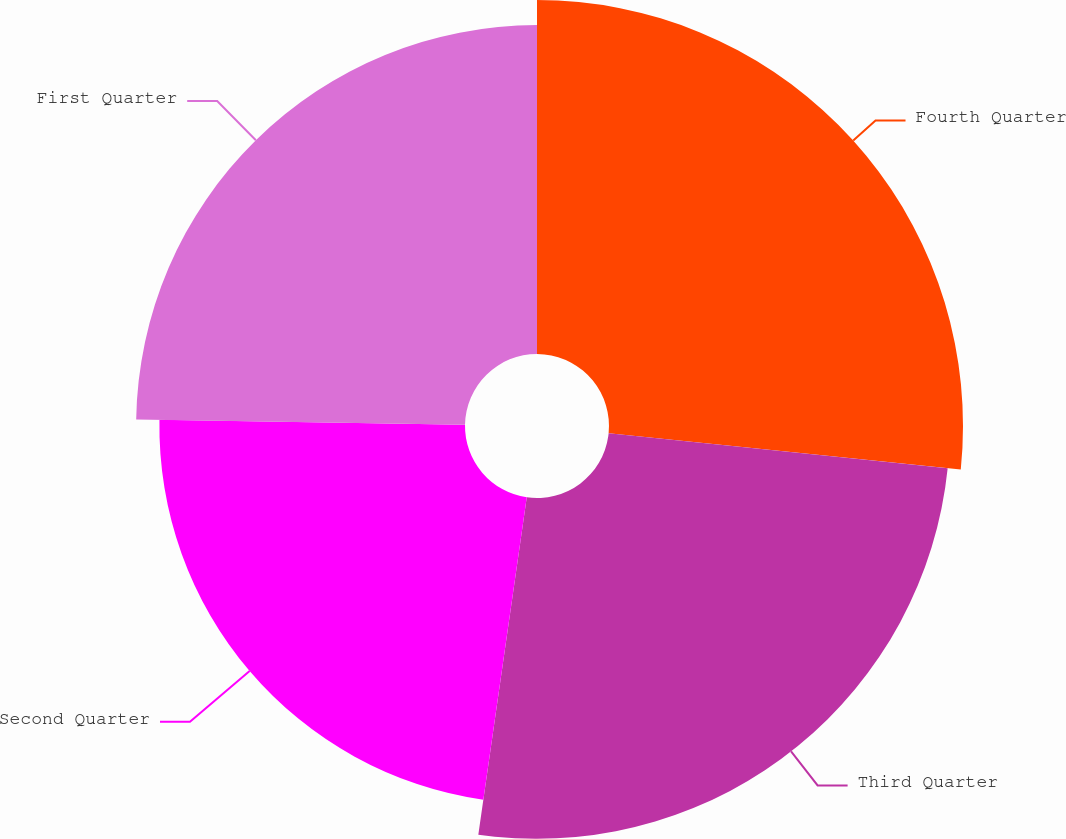<chart> <loc_0><loc_0><loc_500><loc_500><pie_chart><fcel>Fourth Quarter<fcel>Third Quarter<fcel>Second Quarter<fcel>First Quarter<nl><fcel>26.63%<fcel>25.64%<fcel>22.99%<fcel>24.74%<nl></chart> 